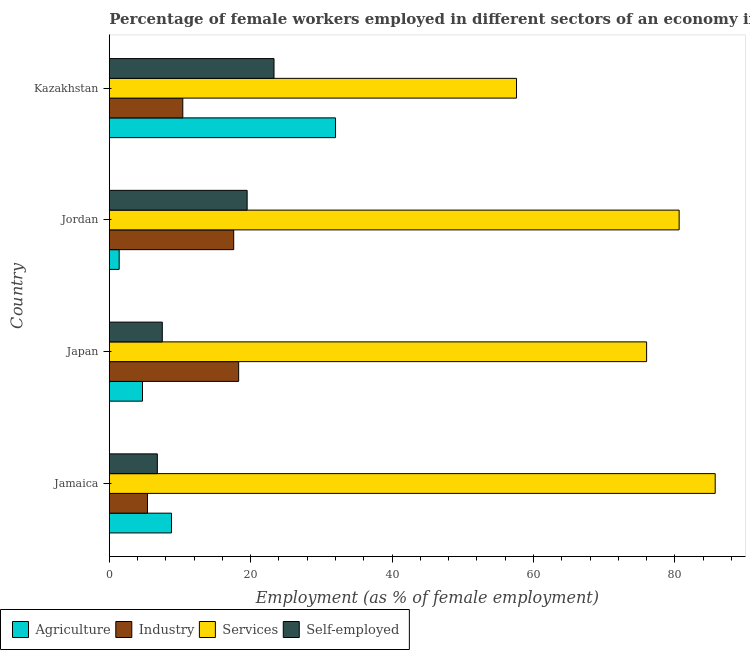Are the number of bars per tick equal to the number of legend labels?
Make the answer very short. Yes. Are the number of bars on each tick of the Y-axis equal?
Your answer should be very brief. Yes. How many bars are there on the 1st tick from the top?
Provide a succinct answer. 4. What is the label of the 1st group of bars from the top?
Give a very brief answer. Kazakhstan. What is the percentage of self employed female workers in Kazakhstan?
Keep it short and to the point. 23.3. Across all countries, what is the minimum percentage of female workers in services?
Provide a succinct answer. 57.6. In which country was the percentage of female workers in services maximum?
Your answer should be very brief. Jamaica. In which country was the percentage of self employed female workers minimum?
Your answer should be compact. Jamaica. What is the total percentage of female workers in services in the graph?
Ensure brevity in your answer.  299.9. What is the difference between the percentage of female workers in services in Japan and the percentage of female workers in agriculture in Kazakhstan?
Give a very brief answer. 44. What is the average percentage of self employed female workers per country?
Offer a very short reply. 14.28. What is the difference between the percentage of female workers in services and percentage of female workers in agriculture in Jordan?
Make the answer very short. 79.2. In how many countries, is the percentage of female workers in agriculture greater than 84 %?
Ensure brevity in your answer.  0. What is the ratio of the percentage of female workers in services in Japan to that in Kazakhstan?
Your answer should be very brief. 1.32. Is the percentage of female workers in agriculture in Japan less than that in Kazakhstan?
Offer a very short reply. Yes. Is the difference between the percentage of female workers in agriculture in Jamaica and Japan greater than the difference between the percentage of female workers in industry in Jamaica and Japan?
Ensure brevity in your answer.  Yes. What is the difference between the highest and the second highest percentage of female workers in industry?
Your response must be concise. 0.7. What is the difference between the highest and the lowest percentage of female workers in services?
Offer a very short reply. 28.1. In how many countries, is the percentage of female workers in industry greater than the average percentage of female workers in industry taken over all countries?
Keep it short and to the point. 2. Is the sum of the percentage of female workers in services in Jamaica and Japan greater than the maximum percentage of self employed female workers across all countries?
Ensure brevity in your answer.  Yes. What does the 1st bar from the top in Jordan represents?
Provide a short and direct response. Self-employed. What does the 4th bar from the bottom in Japan represents?
Offer a very short reply. Self-employed. Is it the case that in every country, the sum of the percentage of female workers in agriculture and percentage of female workers in industry is greater than the percentage of female workers in services?
Provide a succinct answer. No. How many bars are there?
Give a very brief answer. 16. What is the difference between two consecutive major ticks on the X-axis?
Ensure brevity in your answer.  20. Are the values on the major ticks of X-axis written in scientific E-notation?
Offer a terse response. No. Does the graph contain any zero values?
Your answer should be very brief. No. Does the graph contain grids?
Your answer should be compact. No. How many legend labels are there?
Your answer should be compact. 4. How are the legend labels stacked?
Provide a succinct answer. Horizontal. What is the title of the graph?
Your answer should be compact. Percentage of female workers employed in different sectors of an economy in 2004. Does "Natural Gas" appear as one of the legend labels in the graph?
Keep it short and to the point. No. What is the label or title of the X-axis?
Make the answer very short. Employment (as % of female employment). What is the label or title of the Y-axis?
Your answer should be compact. Country. What is the Employment (as % of female employment) of Agriculture in Jamaica?
Give a very brief answer. 8.8. What is the Employment (as % of female employment) in Industry in Jamaica?
Provide a short and direct response. 5.4. What is the Employment (as % of female employment) of Services in Jamaica?
Provide a succinct answer. 85.7. What is the Employment (as % of female employment) in Self-employed in Jamaica?
Your response must be concise. 6.8. What is the Employment (as % of female employment) of Agriculture in Japan?
Keep it short and to the point. 4.7. What is the Employment (as % of female employment) in Industry in Japan?
Your answer should be very brief. 18.3. What is the Employment (as % of female employment) in Agriculture in Jordan?
Provide a succinct answer. 1.4. What is the Employment (as % of female employment) of Industry in Jordan?
Give a very brief answer. 17.6. What is the Employment (as % of female employment) in Services in Jordan?
Provide a succinct answer. 80.6. What is the Employment (as % of female employment) in Industry in Kazakhstan?
Offer a terse response. 10.4. What is the Employment (as % of female employment) in Services in Kazakhstan?
Your answer should be very brief. 57.6. What is the Employment (as % of female employment) in Self-employed in Kazakhstan?
Make the answer very short. 23.3. Across all countries, what is the maximum Employment (as % of female employment) in Industry?
Keep it short and to the point. 18.3. Across all countries, what is the maximum Employment (as % of female employment) of Services?
Give a very brief answer. 85.7. Across all countries, what is the maximum Employment (as % of female employment) in Self-employed?
Your response must be concise. 23.3. Across all countries, what is the minimum Employment (as % of female employment) in Agriculture?
Offer a terse response. 1.4. Across all countries, what is the minimum Employment (as % of female employment) in Industry?
Make the answer very short. 5.4. Across all countries, what is the minimum Employment (as % of female employment) in Services?
Your response must be concise. 57.6. Across all countries, what is the minimum Employment (as % of female employment) of Self-employed?
Your response must be concise. 6.8. What is the total Employment (as % of female employment) of Agriculture in the graph?
Provide a short and direct response. 46.9. What is the total Employment (as % of female employment) of Industry in the graph?
Give a very brief answer. 51.7. What is the total Employment (as % of female employment) of Services in the graph?
Offer a very short reply. 299.9. What is the total Employment (as % of female employment) of Self-employed in the graph?
Your answer should be very brief. 57.1. What is the difference between the Employment (as % of female employment) in Industry in Jamaica and that in Japan?
Offer a very short reply. -12.9. What is the difference between the Employment (as % of female employment) of Self-employed in Jamaica and that in Japan?
Provide a short and direct response. -0.7. What is the difference between the Employment (as % of female employment) of Services in Jamaica and that in Jordan?
Your answer should be compact. 5.1. What is the difference between the Employment (as % of female employment) of Self-employed in Jamaica and that in Jordan?
Keep it short and to the point. -12.7. What is the difference between the Employment (as % of female employment) of Agriculture in Jamaica and that in Kazakhstan?
Your answer should be compact. -23.2. What is the difference between the Employment (as % of female employment) in Industry in Jamaica and that in Kazakhstan?
Ensure brevity in your answer.  -5. What is the difference between the Employment (as % of female employment) in Services in Jamaica and that in Kazakhstan?
Your response must be concise. 28.1. What is the difference between the Employment (as % of female employment) of Self-employed in Jamaica and that in Kazakhstan?
Your answer should be compact. -16.5. What is the difference between the Employment (as % of female employment) in Agriculture in Japan and that in Jordan?
Offer a terse response. 3.3. What is the difference between the Employment (as % of female employment) in Industry in Japan and that in Jordan?
Keep it short and to the point. 0.7. What is the difference between the Employment (as % of female employment) in Agriculture in Japan and that in Kazakhstan?
Make the answer very short. -27.3. What is the difference between the Employment (as % of female employment) of Self-employed in Japan and that in Kazakhstan?
Your answer should be compact. -15.8. What is the difference between the Employment (as % of female employment) in Agriculture in Jordan and that in Kazakhstan?
Provide a short and direct response. -30.6. What is the difference between the Employment (as % of female employment) of Industry in Jordan and that in Kazakhstan?
Your answer should be very brief. 7.2. What is the difference between the Employment (as % of female employment) in Services in Jordan and that in Kazakhstan?
Provide a succinct answer. 23. What is the difference between the Employment (as % of female employment) in Self-employed in Jordan and that in Kazakhstan?
Offer a terse response. -3.8. What is the difference between the Employment (as % of female employment) of Agriculture in Jamaica and the Employment (as % of female employment) of Services in Japan?
Ensure brevity in your answer.  -67.2. What is the difference between the Employment (as % of female employment) of Industry in Jamaica and the Employment (as % of female employment) of Services in Japan?
Offer a terse response. -70.6. What is the difference between the Employment (as % of female employment) in Services in Jamaica and the Employment (as % of female employment) in Self-employed in Japan?
Keep it short and to the point. 78.2. What is the difference between the Employment (as % of female employment) in Agriculture in Jamaica and the Employment (as % of female employment) in Industry in Jordan?
Make the answer very short. -8.8. What is the difference between the Employment (as % of female employment) in Agriculture in Jamaica and the Employment (as % of female employment) in Services in Jordan?
Give a very brief answer. -71.8. What is the difference between the Employment (as % of female employment) in Industry in Jamaica and the Employment (as % of female employment) in Services in Jordan?
Provide a succinct answer. -75.2. What is the difference between the Employment (as % of female employment) in Industry in Jamaica and the Employment (as % of female employment) in Self-employed in Jordan?
Provide a succinct answer. -14.1. What is the difference between the Employment (as % of female employment) of Services in Jamaica and the Employment (as % of female employment) of Self-employed in Jordan?
Offer a terse response. 66.2. What is the difference between the Employment (as % of female employment) in Agriculture in Jamaica and the Employment (as % of female employment) in Services in Kazakhstan?
Your answer should be compact. -48.8. What is the difference between the Employment (as % of female employment) in Industry in Jamaica and the Employment (as % of female employment) in Services in Kazakhstan?
Ensure brevity in your answer.  -52.2. What is the difference between the Employment (as % of female employment) of Industry in Jamaica and the Employment (as % of female employment) of Self-employed in Kazakhstan?
Ensure brevity in your answer.  -17.9. What is the difference between the Employment (as % of female employment) of Services in Jamaica and the Employment (as % of female employment) of Self-employed in Kazakhstan?
Give a very brief answer. 62.4. What is the difference between the Employment (as % of female employment) of Agriculture in Japan and the Employment (as % of female employment) of Services in Jordan?
Provide a succinct answer. -75.9. What is the difference between the Employment (as % of female employment) in Agriculture in Japan and the Employment (as % of female employment) in Self-employed in Jordan?
Make the answer very short. -14.8. What is the difference between the Employment (as % of female employment) in Industry in Japan and the Employment (as % of female employment) in Services in Jordan?
Give a very brief answer. -62.3. What is the difference between the Employment (as % of female employment) in Services in Japan and the Employment (as % of female employment) in Self-employed in Jordan?
Offer a terse response. 56.5. What is the difference between the Employment (as % of female employment) of Agriculture in Japan and the Employment (as % of female employment) of Services in Kazakhstan?
Offer a very short reply. -52.9. What is the difference between the Employment (as % of female employment) of Agriculture in Japan and the Employment (as % of female employment) of Self-employed in Kazakhstan?
Offer a terse response. -18.6. What is the difference between the Employment (as % of female employment) of Industry in Japan and the Employment (as % of female employment) of Services in Kazakhstan?
Offer a terse response. -39.3. What is the difference between the Employment (as % of female employment) in Services in Japan and the Employment (as % of female employment) in Self-employed in Kazakhstan?
Provide a succinct answer. 52.7. What is the difference between the Employment (as % of female employment) in Agriculture in Jordan and the Employment (as % of female employment) in Industry in Kazakhstan?
Your answer should be compact. -9. What is the difference between the Employment (as % of female employment) in Agriculture in Jordan and the Employment (as % of female employment) in Services in Kazakhstan?
Give a very brief answer. -56.2. What is the difference between the Employment (as % of female employment) of Agriculture in Jordan and the Employment (as % of female employment) of Self-employed in Kazakhstan?
Provide a short and direct response. -21.9. What is the difference between the Employment (as % of female employment) in Industry in Jordan and the Employment (as % of female employment) in Services in Kazakhstan?
Your answer should be compact. -40. What is the difference between the Employment (as % of female employment) in Industry in Jordan and the Employment (as % of female employment) in Self-employed in Kazakhstan?
Your answer should be very brief. -5.7. What is the difference between the Employment (as % of female employment) of Services in Jordan and the Employment (as % of female employment) of Self-employed in Kazakhstan?
Provide a succinct answer. 57.3. What is the average Employment (as % of female employment) of Agriculture per country?
Give a very brief answer. 11.72. What is the average Employment (as % of female employment) of Industry per country?
Provide a succinct answer. 12.93. What is the average Employment (as % of female employment) in Services per country?
Your answer should be compact. 74.97. What is the average Employment (as % of female employment) in Self-employed per country?
Your answer should be compact. 14.28. What is the difference between the Employment (as % of female employment) of Agriculture and Employment (as % of female employment) of Industry in Jamaica?
Make the answer very short. 3.4. What is the difference between the Employment (as % of female employment) in Agriculture and Employment (as % of female employment) in Services in Jamaica?
Provide a succinct answer. -76.9. What is the difference between the Employment (as % of female employment) of Agriculture and Employment (as % of female employment) of Self-employed in Jamaica?
Provide a succinct answer. 2. What is the difference between the Employment (as % of female employment) of Industry and Employment (as % of female employment) of Services in Jamaica?
Offer a terse response. -80.3. What is the difference between the Employment (as % of female employment) in Industry and Employment (as % of female employment) in Self-employed in Jamaica?
Ensure brevity in your answer.  -1.4. What is the difference between the Employment (as % of female employment) in Services and Employment (as % of female employment) in Self-employed in Jamaica?
Your response must be concise. 78.9. What is the difference between the Employment (as % of female employment) of Agriculture and Employment (as % of female employment) of Services in Japan?
Make the answer very short. -71.3. What is the difference between the Employment (as % of female employment) in Industry and Employment (as % of female employment) in Services in Japan?
Keep it short and to the point. -57.7. What is the difference between the Employment (as % of female employment) in Services and Employment (as % of female employment) in Self-employed in Japan?
Offer a terse response. 68.5. What is the difference between the Employment (as % of female employment) in Agriculture and Employment (as % of female employment) in Industry in Jordan?
Give a very brief answer. -16.2. What is the difference between the Employment (as % of female employment) in Agriculture and Employment (as % of female employment) in Services in Jordan?
Give a very brief answer. -79.2. What is the difference between the Employment (as % of female employment) in Agriculture and Employment (as % of female employment) in Self-employed in Jordan?
Give a very brief answer. -18.1. What is the difference between the Employment (as % of female employment) in Industry and Employment (as % of female employment) in Services in Jordan?
Provide a short and direct response. -63. What is the difference between the Employment (as % of female employment) of Services and Employment (as % of female employment) of Self-employed in Jordan?
Your answer should be very brief. 61.1. What is the difference between the Employment (as % of female employment) in Agriculture and Employment (as % of female employment) in Industry in Kazakhstan?
Ensure brevity in your answer.  21.6. What is the difference between the Employment (as % of female employment) in Agriculture and Employment (as % of female employment) in Services in Kazakhstan?
Ensure brevity in your answer.  -25.6. What is the difference between the Employment (as % of female employment) of Agriculture and Employment (as % of female employment) of Self-employed in Kazakhstan?
Make the answer very short. 8.7. What is the difference between the Employment (as % of female employment) in Industry and Employment (as % of female employment) in Services in Kazakhstan?
Ensure brevity in your answer.  -47.2. What is the difference between the Employment (as % of female employment) of Services and Employment (as % of female employment) of Self-employed in Kazakhstan?
Offer a very short reply. 34.3. What is the ratio of the Employment (as % of female employment) of Agriculture in Jamaica to that in Japan?
Give a very brief answer. 1.87. What is the ratio of the Employment (as % of female employment) of Industry in Jamaica to that in Japan?
Give a very brief answer. 0.3. What is the ratio of the Employment (as % of female employment) in Services in Jamaica to that in Japan?
Your answer should be compact. 1.13. What is the ratio of the Employment (as % of female employment) in Self-employed in Jamaica to that in Japan?
Provide a short and direct response. 0.91. What is the ratio of the Employment (as % of female employment) of Agriculture in Jamaica to that in Jordan?
Offer a very short reply. 6.29. What is the ratio of the Employment (as % of female employment) in Industry in Jamaica to that in Jordan?
Give a very brief answer. 0.31. What is the ratio of the Employment (as % of female employment) of Services in Jamaica to that in Jordan?
Offer a terse response. 1.06. What is the ratio of the Employment (as % of female employment) of Self-employed in Jamaica to that in Jordan?
Make the answer very short. 0.35. What is the ratio of the Employment (as % of female employment) in Agriculture in Jamaica to that in Kazakhstan?
Offer a very short reply. 0.28. What is the ratio of the Employment (as % of female employment) in Industry in Jamaica to that in Kazakhstan?
Your answer should be very brief. 0.52. What is the ratio of the Employment (as % of female employment) of Services in Jamaica to that in Kazakhstan?
Ensure brevity in your answer.  1.49. What is the ratio of the Employment (as % of female employment) of Self-employed in Jamaica to that in Kazakhstan?
Provide a short and direct response. 0.29. What is the ratio of the Employment (as % of female employment) in Agriculture in Japan to that in Jordan?
Your answer should be compact. 3.36. What is the ratio of the Employment (as % of female employment) of Industry in Japan to that in Jordan?
Give a very brief answer. 1.04. What is the ratio of the Employment (as % of female employment) in Services in Japan to that in Jordan?
Ensure brevity in your answer.  0.94. What is the ratio of the Employment (as % of female employment) of Self-employed in Japan to that in Jordan?
Keep it short and to the point. 0.38. What is the ratio of the Employment (as % of female employment) in Agriculture in Japan to that in Kazakhstan?
Offer a terse response. 0.15. What is the ratio of the Employment (as % of female employment) in Industry in Japan to that in Kazakhstan?
Your response must be concise. 1.76. What is the ratio of the Employment (as % of female employment) of Services in Japan to that in Kazakhstan?
Your answer should be compact. 1.32. What is the ratio of the Employment (as % of female employment) in Self-employed in Japan to that in Kazakhstan?
Give a very brief answer. 0.32. What is the ratio of the Employment (as % of female employment) of Agriculture in Jordan to that in Kazakhstan?
Your response must be concise. 0.04. What is the ratio of the Employment (as % of female employment) in Industry in Jordan to that in Kazakhstan?
Provide a succinct answer. 1.69. What is the ratio of the Employment (as % of female employment) of Services in Jordan to that in Kazakhstan?
Your response must be concise. 1.4. What is the ratio of the Employment (as % of female employment) of Self-employed in Jordan to that in Kazakhstan?
Provide a succinct answer. 0.84. What is the difference between the highest and the second highest Employment (as % of female employment) in Agriculture?
Keep it short and to the point. 23.2. What is the difference between the highest and the second highest Employment (as % of female employment) in Industry?
Provide a short and direct response. 0.7. What is the difference between the highest and the second highest Employment (as % of female employment) in Services?
Your answer should be compact. 5.1. What is the difference between the highest and the lowest Employment (as % of female employment) of Agriculture?
Offer a terse response. 30.6. What is the difference between the highest and the lowest Employment (as % of female employment) in Industry?
Provide a succinct answer. 12.9. What is the difference between the highest and the lowest Employment (as % of female employment) of Services?
Your response must be concise. 28.1. 